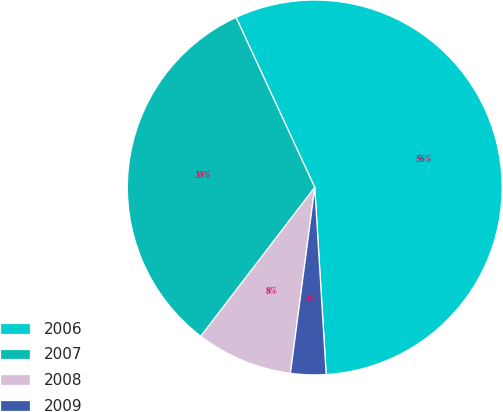Convert chart. <chart><loc_0><loc_0><loc_500><loc_500><pie_chart><fcel>2006<fcel>2007<fcel>2008<fcel>2009<nl><fcel>55.93%<fcel>32.7%<fcel>8.33%<fcel>3.04%<nl></chart> 